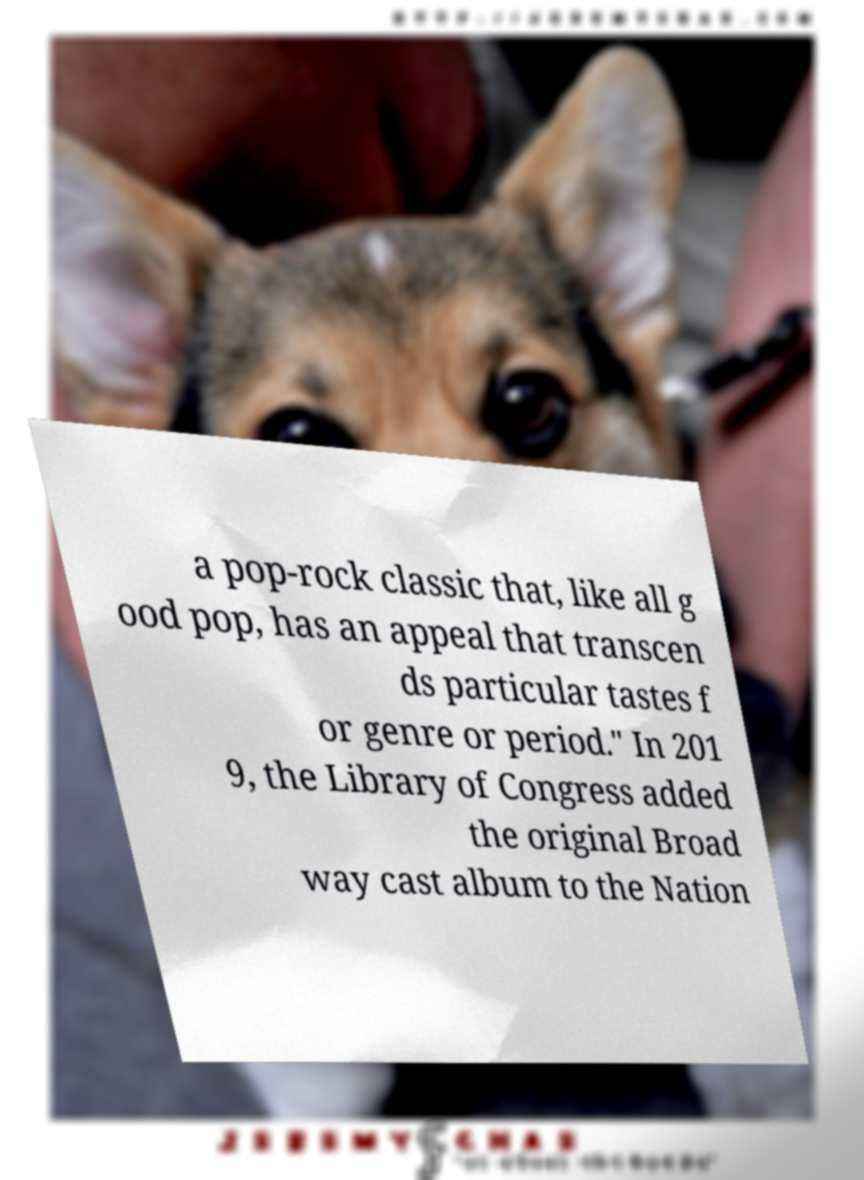Could you extract and type out the text from this image? a pop-rock classic that, like all g ood pop, has an appeal that transcen ds particular tastes f or genre or period." In 201 9, the Library of Congress added the original Broad way cast album to the Nation 